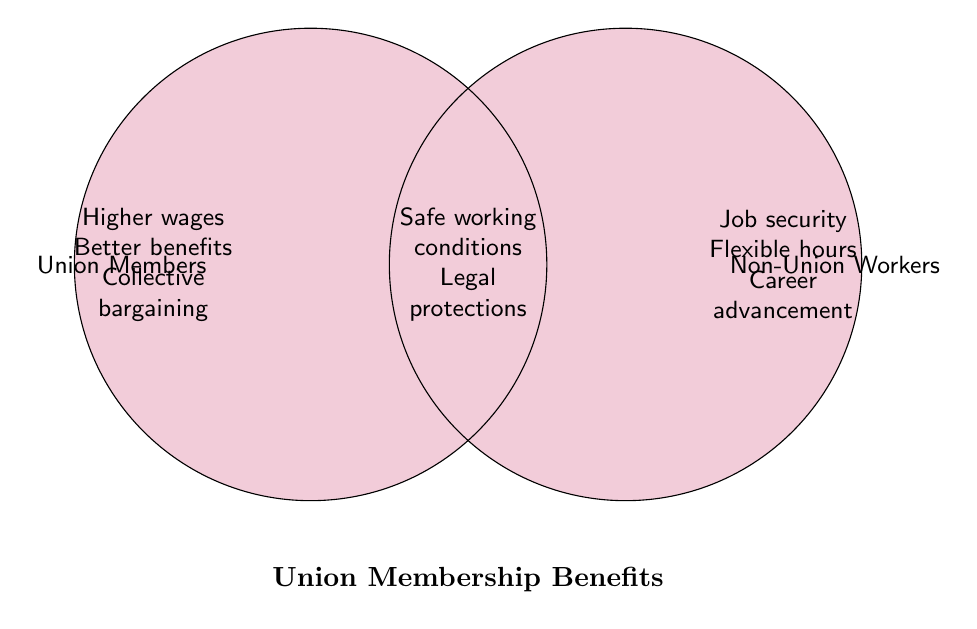What is the title of the figure? The title is displayed at the bottom of the Venn diagram. It reads "Union Membership Benefits".
Answer: Union Membership Benefits What are the unique benefits for Union Members as shown in the figure? The benefits are listed in the left part of the Venn diagram, only in the Union Members circle. They include "Higher wages", "Better benefits", and "Collective bargaining".
Answer: Higher wages, Better benefits, Collective bargaining What are the unique benefits for Non-Union Workers? The benefits are listed in the right part of the Venn diagram, only in the Non-Union Workers circle. They include "Job security", "Flexible hours", and "Career advancement".
Answer: Job security, Flexible hours, Career advancement Which benefits are shared between Union Members and Non-Union Workers? The shared benefits are located in the overlapping section of the Venn diagram. These include "Safe working conditions" and "Legal protections".
Answer: Safe working conditions, Legal protections Are "Flexible hours" a benefit for Union Members? "Flexible hours" are located in the right circle of the Venn diagram, indicating it's a benefit for Non-Union Workers, not Union Members.
Answer: No What type of workers have "Collective bargaining" as a benefit? "Collective bargaining" is listed in the left circle of the Venn diagram, indicating it's a benefit for Union Members.
Answer: Union Members How does the benefit of "Health insurance" relate to Union Members and Non-Union Workers? "Health insurance" isn't explicitly shown in the Venn diagram, so it may not be a benefit listed for either group.
Answer: Not shown Which benefit is only associated with "Career advancement"? "Career advancement" appears in the right circle of the Venn diagram, indicating it's a unique benefit for Non-Union Workers.
Answer: Non-Union Workers Which group has more unique benefits mentioned in the figure? Union Members have three unique benefits listed: "Higher wages", "Better benefits", and "Collective bargaining". Non-Union Workers also have three: "Job security", "Flexible hours", and "Career advancement". The number is the same for both groups.
Answer: Same Are "Higher wages" and "Legal protections" benefits that belong to the same group? "Higher wages" is a benefit only listed for Union Members, while "Legal protections" are shared between both groups in the overlapping section.
Answer: No 